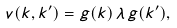Convert formula to latex. <formula><loc_0><loc_0><loc_500><loc_500>v ( k , k ^ { \prime } ) = g ( k ) \, \lambda \, g ( k ^ { \prime } ) ,</formula> 